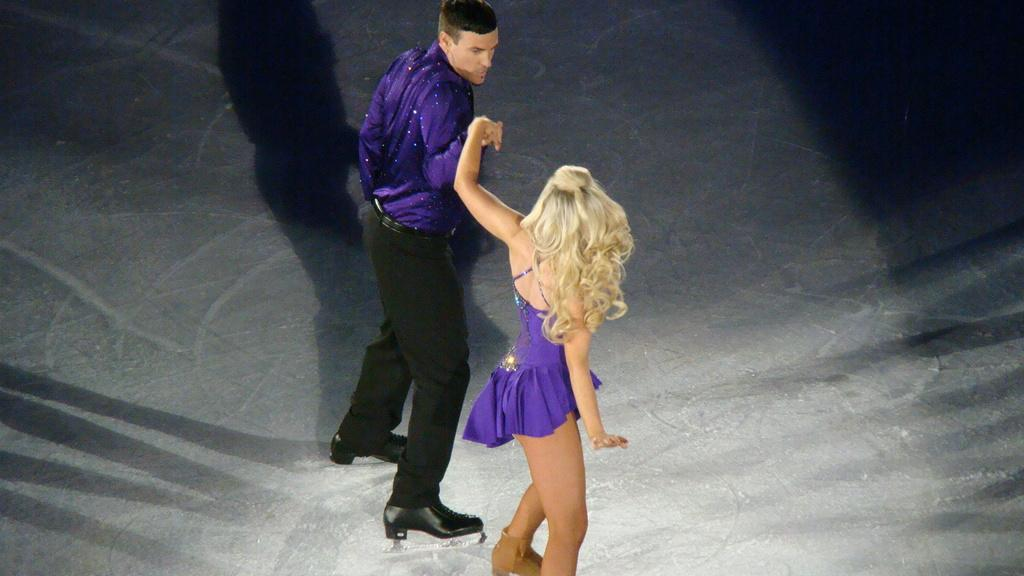How many people are present in the image? There are two people in the image, a man and a woman. What are the positions of the man and the woman in the image? Both the man and the woman are standing on the floor. Can you describe any additional features in the image? There is a shadow visible on the floor. What division is taking place in the image? There is no division taking place in the image. 